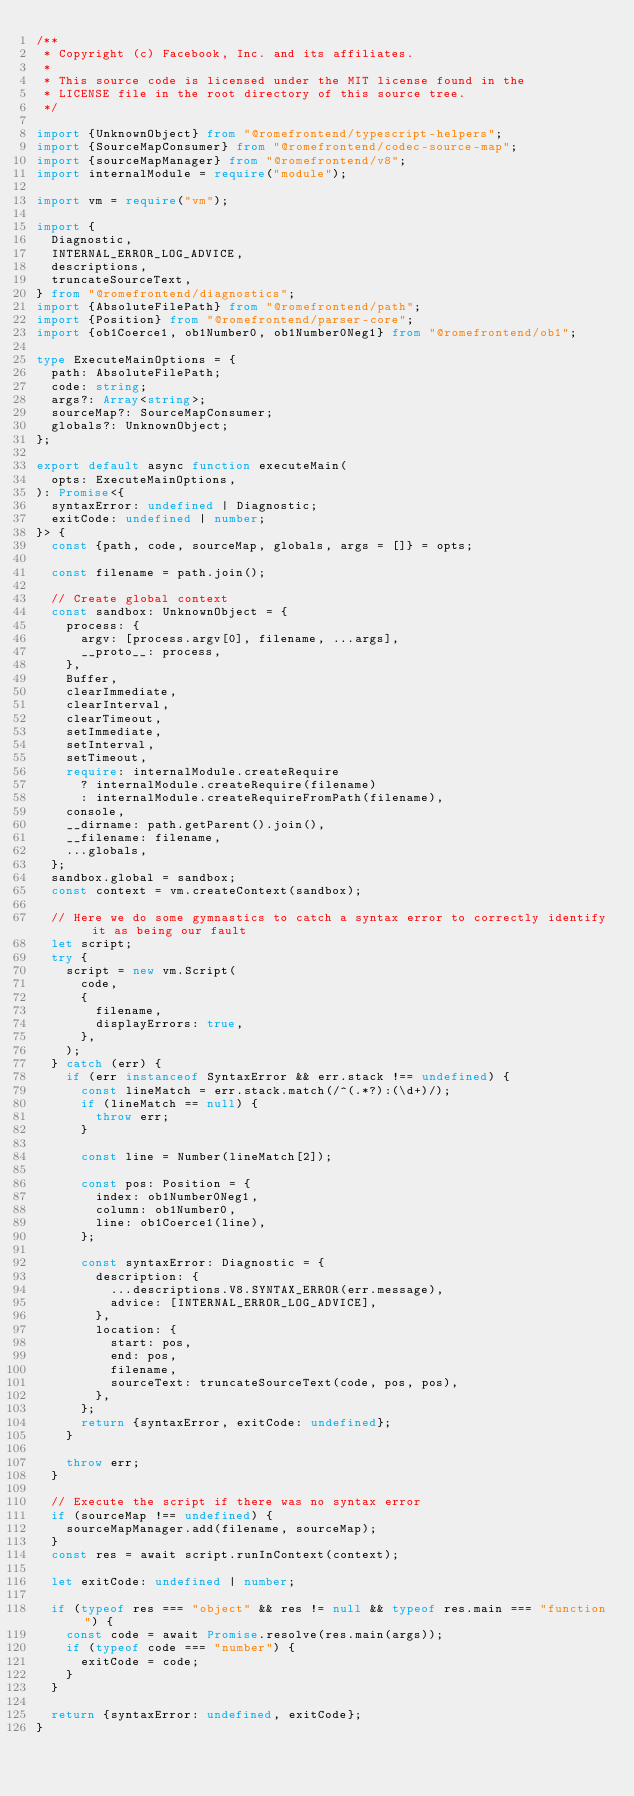Convert code to text. <code><loc_0><loc_0><loc_500><loc_500><_TypeScript_>/**
 * Copyright (c) Facebook, Inc. and its affiliates.
 *
 * This source code is licensed under the MIT license found in the
 * LICENSE file in the root directory of this source tree.
 */

import {UnknownObject} from "@romefrontend/typescript-helpers";
import {SourceMapConsumer} from "@romefrontend/codec-source-map";
import {sourceMapManager} from "@romefrontend/v8";
import internalModule = require("module");

import vm = require("vm");

import {
	Diagnostic,
	INTERNAL_ERROR_LOG_ADVICE,
	descriptions,
	truncateSourceText,
} from "@romefrontend/diagnostics";
import {AbsoluteFilePath} from "@romefrontend/path";
import {Position} from "@romefrontend/parser-core";
import {ob1Coerce1, ob1Number0, ob1Number0Neg1} from "@romefrontend/ob1";

type ExecuteMainOptions = {
	path: AbsoluteFilePath;
	code: string;
	args?: Array<string>;
	sourceMap?: SourceMapConsumer;
	globals?: UnknownObject;
};

export default async function executeMain(
	opts: ExecuteMainOptions,
): Promise<{
	syntaxError: undefined | Diagnostic;
	exitCode: undefined | number;
}> {
	const {path, code, sourceMap, globals, args = []} = opts;

	const filename = path.join();

	// Create global context
	const sandbox: UnknownObject = {
		process: {
			argv: [process.argv[0], filename, ...args],
			__proto__: process,
		},
		Buffer,
		clearImmediate,
		clearInterval,
		clearTimeout,
		setImmediate,
		setInterval,
		setTimeout,
		require: internalModule.createRequire
			? internalModule.createRequire(filename)
			: internalModule.createRequireFromPath(filename),
		console,
		__dirname: path.getParent().join(),
		__filename: filename,
		...globals,
	};
	sandbox.global = sandbox;
	const context = vm.createContext(sandbox);

	// Here we do some gymnastics to catch a syntax error to correctly identify it as being our fault
	let script;
	try {
		script = new vm.Script(
			code,
			{
				filename,
				displayErrors: true,
			},
		);
	} catch (err) {
		if (err instanceof SyntaxError && err.stack !== undefined) {
			const lineMatch = err.stack.match(/^(.*?):(\d+)/);
			if (lineMatch == null) {
				throw err;
			}

			const line = Number(lineMatch[2]);

			const pos: Position = {
				index: ob1Number0Neg1,
				column: ob1Number0,
				line: ob1Coerce1(line),
			};

			const syntaxError: Diagnostic = {
				description: {
					...descriptions.V8.SYNTAX_ERROR(err.message),
					advice: [INTERNAL_ERROR_LOG_ADVICE],
				},
				location: {
					start: pos,
					end: pos,
					filename,
					sourceText: truncateSourceText(code, pos, pos),
				},
			};
			return {syntaxError, exitCode: undefined};
		}

		throw err;
	}

	// Execute the script if there was no syntax error
	if (sourceMap !== undefined) {
		sourceMapManager.add(filename, sourceMap);
	}
	const res = await script.runInContext(context);

	let exitCode: undefined | number;

	if (typeof res === "object" && res != null && typeof res.main === "function") {
		const code = await Promise.resolve(res.main(args));
		if (typeof code === "number") {
			exitCode = code;
		}
	}

	return {syntaxError: undefined, exitCode};
}
</code> 